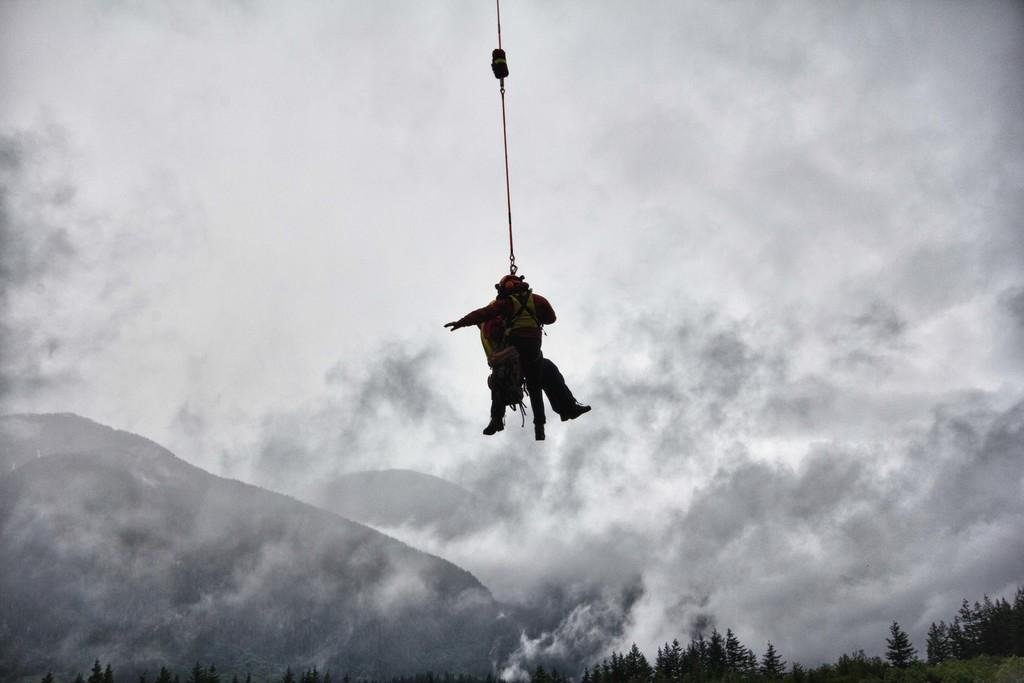How many people are in the image? There are two persons in the image. What are the two persons doing in the image? The two persons are in the air, and a rope is tightened to them. What can be seen in the right bottom corner of the image? There are trees in the right bottom corner of the image. What is the condition of the sky in the image? The background of the image is cloudy. How many horses are present in the image? There are no horses present in the image. Can you tell me how many kittens are playing on the rope? There are no kittens present in the image. 